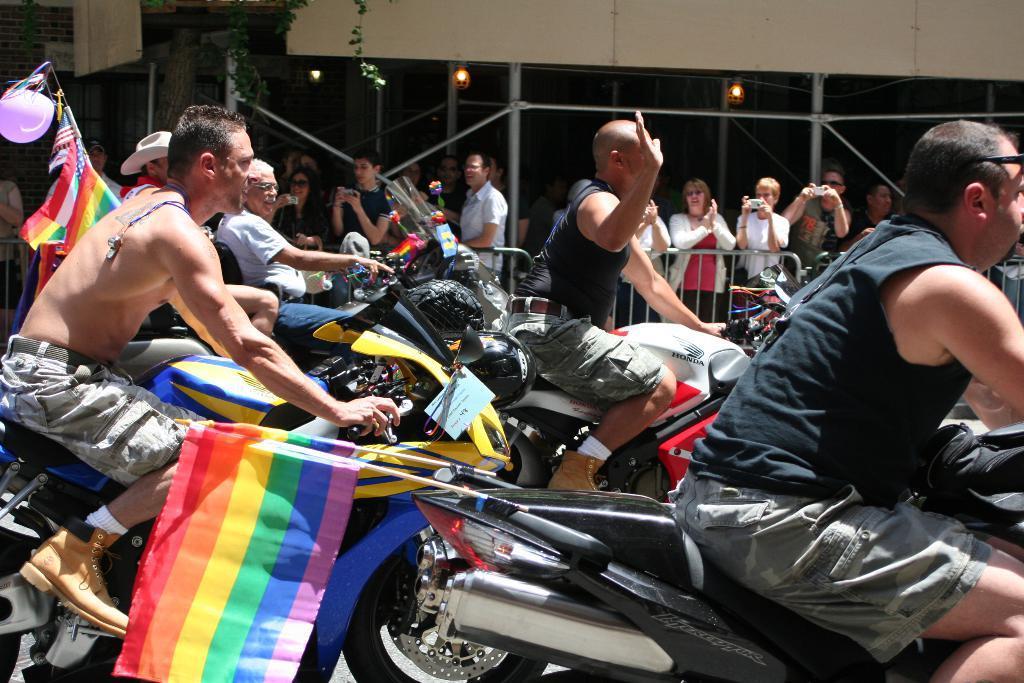Please provide a concise description of this image. In this picture we can see a group of men riding bikes with flags to it on road and beside to them we have fence and people standing and clapping hands and some are holding cameras and in background we can see tree, light. 